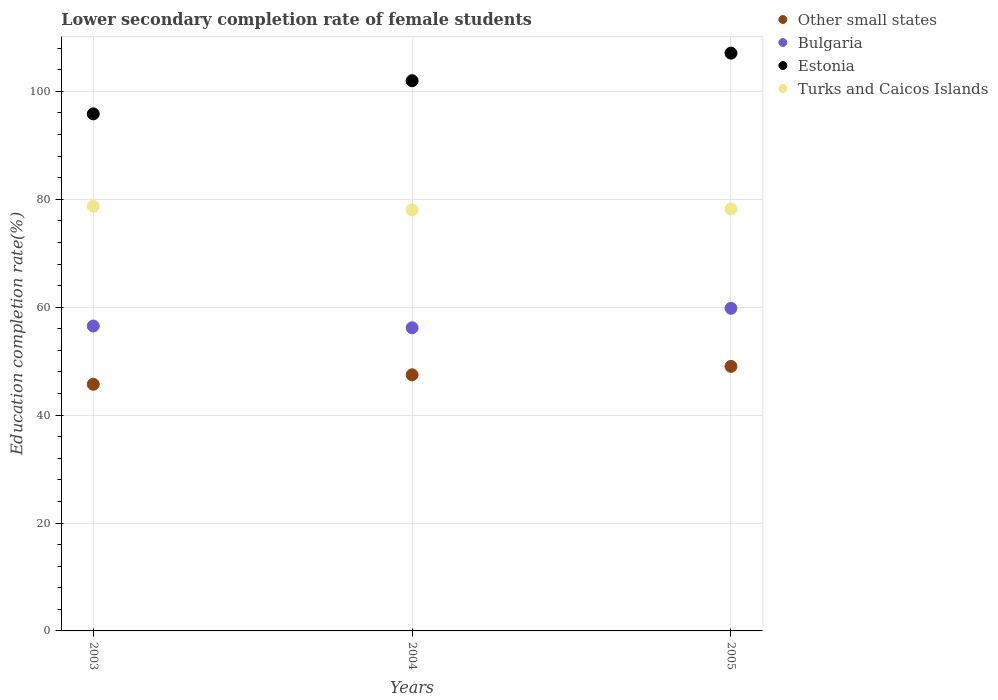Is the number of dotlines equal to the number of legend labels?
Offer a terse response. Yes. What is the lower secondary completion rate of female students in Turks and Caicos Islands in 2003?
Offer a terse response. 78.71. Across all years, what is the maximum lower secondary completion rate of female students in Bulgaria?
Your answer should be compact. 59.8. Across all years, what is the minimum lower secondary completion rate of female students in Other small states?
Give a very brief answer. 45.72. In which year was the lower secondary completion rate of female students in Bulgaria maximum?
Provide a short and direct response. 2005. What is the total lower secondary completion rate of female students in Turks and Caicos Islands in the graph?
Offer a terse response. 234.97. What is the difference between the lower secondary completion rate of female students in Other small states in 2004 and that in 2005?
Offer a very short reply. -1.56. What is the difference between the lower secondary completion rate of female students in Turks and Caicos Islands in 2003 and the lower secondary completion rate of female students in Other small states in 2005?
Ensure brevity in your answer.  29.68. What is the average lower secondary completion rate of female students in Bulgaria per year?
Give a very brief answer. 57.5. In the year 2003, what is the difference between the lower secondary completion rate of female students in Other small states and lower secondary completion rate of female students in Turks and Caicos Islands?
Your answer should be compact. -32.99. What is the ratio of the lower secondary completion rate of female students in Estonia in 2004 to that in 2005?
Your response must be concise. 0.95. What is the difference between the highest and the second highest lower secondary completion rate of female students in Bulgaria?
Keep it short and to the point. 3.28. What is the difference between the highest and the lowest lower secondary completion rate of female students in Estonia?
Make the answer very short. 11.26. Is the sum of the lower secondary completion rate of female students in Bulgaria in 2004 and 2005 greater than the maximum lower secondary completion rate of female students in Other small states across all years?
Provide a short and direct response. Yes. Is it the case that in every year, the sum of the lower secondary completion rate of female students in Bulgaria and lower secondary completion rate of female students in Turks and Caicos Islands  is greater than the sum of lower secondary completion rate of female students in Other small states and lower secondary completion rate of female students in Estonia?
Your response must be concise. No. Is it the case that in every year, the sum of the lower secondary completion rate of female students in Turks and Caicos Islands and lower secondary completion rate of female students in Estonia  is greater than the lower secondary completion rate of female students in Other small states?
Your answer should be very brief. Yes. Are the values on the major ticks of Y-axis written in scientific E-notation?
Your answer should be very brief. No. Does the graph contain any zero values?
Provide a short and direct response. No. Where does the legend appear in the graph?
Your answer should be very brief. Top right. How many legend labels are there?
Give a very brief answer. 4. What is the title of the graph?
Provide a succinct answer. Lower secondary completion rate of female students. Does "Tonga" appear as one of the legend labels in the graph?
Your answer should be compact. No. What is the label or title of the X-axis?
Your answer should be compact. Years. What is the label or title of the Y-axis?
Keep it short and to the point. Education completion rate(%). What is the Education completion rate(%) in Other small states in 2003?
Keep it short and to the point. 45.72. What is the Education completion rate(%) in Bulgaria in 2003?
Your answer should be very brief. 56.52. What is the Education completion rate(%) in Estonia in 2003?
Keep it short and to the point. 95.84. What is the Education completion rate(%) of Turks and Caicos Islands in 2003?
Provide a succinct answer. 78.71. What is the Education completion rate(%) in Other small states in 2004?
Offer a terse response. 47.47. What is the Education completion rate(%) of Bulgaria in 2004?
Your answer should be compact. 56.19. What is the Education completion rate(%) in Estonia in 2004?
Your answer should be very brief. 101.99. What is the Education completion rate(%) in Turks and Caicos Islands in 2004?
Give a very brief answer. 78.05. What is the Education completion rate(%) in Other small states in 2005?
Provide a short and direct response. 49.03. What is the Education completion rate(%) of Bulgaria in 2005?
Make the answer very short. 59.8. What is the Education completion rate(%) of Estonia in 2005?
Provide a short and direct response. 107.1. What is the Education completion rate(%) in Turks and Caicos Islands in 2005?
Your answer should be very brief. 78.21. Across all years, what is the maximum Education completion rate(%) of Other small states?
Keep it short and to the point. 49.03. Across all years, what is the maximum Education completion rate(%) in Bulgaria?
Your response must be concise. 59.8. Across all years, what is the maximum Education completion rate(%) of Estonia?
Provide a short and direct response. 107.1. Across all years, what is the maximum Education completion rate(%) in Turks and Caicos Islands?
Ensure brevity in your answer.  78.71. Across all years, what is the minimum Education completion rate(%) of Other small states?
Provide a succinct answer. 45.72. Across all years, what is the minimum Education completion rate(%) in Bulgaria?
Ensure brevity in your answer.  56.19. Across all years, what is the minimum Education completion rate(%) of Estonia?
Give a very brief answer. 95.84. Across all years, what is the minimum Education completion rate(%) in Turks and Caicos Islands?
Your answer should be very brief. 78.05. What is the total Education completion rate(%) of Other small states in the graph?
Your response must be concise. 142.22. What is the total Education completion rate(%) in Bulgaria in the graph?
Your answer should be very brief. 172.51. What is the total Education completion rate(%) of Estonia in the graph?
Offer a terse response. 304.92. What is the total Education completion rate(%) of Turks and Caicos Islands in the graph?
Offer a very short reply. 234.97. What is the difference between the Education completion rate(%) of Other small states in 2003 and that in 2004?
Your answer should be compact. -1.76. What is the difference between the Education completion rate(%) in Bulgaria in 2003 and that in 2004?
Your response must be concise. 0.33. What is the difference between the Education completion rate(%) of Estonia in 2003 and that in 2004?
Provide a short and direct response. -6.15. What is the difference between the Education completion rate(%) of Turks and Caicos Islands in 2003 and that in 2004?
Give a very brief answer. 0.66. What is the difference between the Education completion rate(%) in Other small states in 2003 and that in 2005?
Provide a succinct answer. -3.31. What is the difference between the Education completion rate(%) of Bulgaria in 2003 and that in 2005?
Keep it short and to the point. -3.28. What is the difference between the Education completion rate(%) in Estonia in 2003 and that in 2005?
Offer a terse response. -11.26. What is the difference between the Education completion rate(%) in Turks and Caicos Islands in 2003 and that in 2005?
Provide a short and direct response. 0.5. What is the difference between the Education completion rate(%) of Other small states in 2004 and that in 2005?
Your answer should be very brief. -1.56. What is the difference between the Education completion rate(%) of Bulgaria in 2004 and that in 2005?
Provide a succinct answer. -3.61. What is the difference between the Education completion rate(%) in Estonia in 2004 and that in 2005?
Your response must be concise. -5.11. What is the difference between the Education completion rate(%) in Turks and Caicos Islands in 2004 and that in 2005?
Make the answer very short. -0.16. What is the difference between the Education completion rate(%) of Other small states in 2003 and the Education completion rate(%) of Bulgaria in 2004?
Give a very brief answer. -10.47. What is the difference between the Education completion rate(%) in Other small states in 2003 and the Education completion rate(%) in Estonia in 2004?
Offer a very short reply. -56.27. What is the difference between the Education completion rate(%) in Other small states in 2003 and the Education completion rate(%) in Turks and Caicos Islands in 2004?
Make the answer very short. -32.33. What is the difference between the Education completion rate(%) in Bulgaria in 2003 and the Education completion rate(%) in Estonia in 2004?
Provide a short and direct response. -45.47. What is the difference between the Education completion rate(%) of Bulgaria in 2003 and the Education completion rate(%) of Turks and Caicos Islands in 2004?
Keep it short and to the point. -21.53. What is the difference between the Education completion rate(%) of Estonia in 2003 and the Education completion rate(%) of Turks and Caicos Islands in 2004?
Make the answer very short. 17.79. What is the difference between the Education completion rate(%) of Other small states in 2003 and the Education completion rate(%) of Bulgaria in 2005?
Provide a short and direct response. -14.08. What is the difference between the Education completion rate(%) of Other small states in 2003 and the Education completion rate(%) of Estonia in 2005?
Offer a terse response. -61.38. What is the difference between the Education completion rate(%) of Other small states in 2003 and the Education completion rate(%) of Turks and Caicos Islands in 2005?
Your response must be concise. -32.49. What is the difference between the Education completion rate(%) in Bulgaria in 2003 and the Education completion rate(%) in Estonia in 2005?
Provide a short and direct response. -50.58. What is the difference between the Education completion rate(%) of Bulgaria in 2003 and the Education completion rate(%) of Turks and Caicos Islands in 2005?
Provide a succinct answer. -21.7. What is the difference between the Education completion rate(%) in Estonia in 2003 and the Education completion rate(%) in Turks and Caicos Islands in 2005?
Your answer should be compact. 17.63. What is the difference between the Education completion rate(%) of Other small states in 2004 and the Education completion rate(%) of Bulgaria in 2005?
Give a very brief answer. -12.33. What is the difference between the Education completion rate(%) of Other small states in 2004 and the Education completion rate(%) of Estonia in 2005?
Provide a succinct answer. -59.62. What is the difference between the Education completion rate(%) in Other small states in 2004 and the Education completion rate(%) in Turks and Caicos Islands in 2005?
Your answer should be very brief. -30.74. What is the difference between the Education completion rate(%) of Bulgaria in 2004 and the Education completion rate(%) of Estonia in 2005?
Give a very brief answer. -50.91. What is the difference between the Education completion rate(%) in Bulgaria in 2004 and the Education completion rate(%) in Turks and Caicos Islands in 2005?
Provide a succinct answer. -22.02. What is the difference between the Education completion rate(%) of Estonia in 2004 and the Education completion rate(%) of Turks and Caicos Islands in 2005?
Offer a terse response. 23.77. What is the average Education completion rate(%) in Other small states per year?
Offer a very short reply. 47.41. What is the average Education completion rate(%) in Bulgaria per year?
Give a very brief answer. 57.5. What is the average Education completion rate(%) of Estonia per year?
Make the answer very short. 101.64. What is the average Education completion rate(%) in Turks and Caicos Islands per year?
Give a very brief answer. 78.32. In the year 2003, what is the difference between the Education completion rate(%) in Other small states and Education completion rate(%) in Bulgaria?
Ensure brevity in your answer.  -10.8. In the year 2003, what is the difference between the Education completion rate(%) of Other small states and Education completion rate(%) of Estonia?
Offer a terse response. -50.12. In the year 2003, what is the difference between the Education completion rate(%) in Other small states and Education completion rate(%) in Turks and Caicos Islands?
Ensure brevity in your answer.  -32.99. In the year 2003, what is the difference between the Education completion rate(%) of Bulgaria and Education completion rate(%) of Estonia?
Your response must be concise. -39.32. In the year 2003, what is the difference between the Education completion rate(%) of Bulgaria and Education completion rate(%) of Turks and Caicos Islands?
Ensure brevity in your answer.  -22.19. In the year 2003, what is the difference between the Education completion rate(%) of Estonia and Education completion rate(%) of Turks and Caicos Islands?
Ensure brevity in your answer.  17.13. In the year 2004, what is the difference between the Education completion rate(%) in Other small states and Education completion rate(%) in Bulgaria?
Provide a short and direct response. -8.72. In the year 2004, what is the difference between the Education completion rate(%) in Other small states and Education completion rate(%) in Estonia?
Give a very brief answer. -54.51. In the year 2004, what is the difference between the Education completion rate(%) in Other small states and Education completion rate(%) in Turks and Caicos Islands?
Make the answer very short. -30.57. In the year 2004, what is the difference between the Education completion rate(%) of Bulgaria and Education completion rate(%) of Estonia?
Keep it short and to the point. -45.8. In the year 2004, what is the difference between the Education completion rate(%) in Bulgaria and Education completion rate(%) in Turks and Caicos Islands?
Offer a terse response. -21.86. In the year 2004, what is the difference between the Education completion rate(%) of Estonia and Education completion rate(%) of Turks and Caicos Islands?
Keep it short and to the point. 23.94. In the year 2005, what is the difference between the Education completion rate(%) in Other small states and Education completion rate(%) in Bulgaria?
Your answer should be compact. -10.77. In the year 2005, what is the difference between the Education completion rate(%) in Other small states and Education completion rate(%) in Estonia?
Provide a short and direct response. -58.07. In the year 2005, what is the difference between the Education completion rate(%) in Other small states and Education completion rate(%) in Turks and Caicos Islands?
Provide a short and direct response. -29.18. In the year 2005, what is the difference between the Education completion rate(%) of Bulgaria and Education completion rate(%) of Estonia?
Your response must be concise. -47.3. In the year 2005, what is the difference between the Education completion rate(%) of Bulgaria and Education completion rate(%) of Turks and Caicos Islands?
Your response must be concise. -18.41. In the year 2005, what is the difference between the Education completion rate(%) of Estonia and Education completion rate(%) of Turks and Caicos Islands?
Your answer should be compact. 28.88. What is the ratio of the Education completion rate(%) of Estonia in 2003 to that in 2004?
Your response must be concise. 0.94. What is the ratio of the Education completion rate(%) of Turks and Caicos Islands in 2003 to that in 2004?
Your answer should be compact. 1.01. What is the ratio of the Education completion rate(%) of Other small states in 2003 to that in 2005?
Provide a succinct answer. 0.93. What is the ratio of the Education completion rate(%) of Bulgaria in 2003 to that in 2005?
Keep it short and to the point. 0.95. What is the ratio of the Education completion rate(%) in Estonia in 2003 to that in 2005?
Keep it short and to the point. 0.89. What is the ratio of the Education completion rate(%) of Turks and Caicos Islands in 2003 to that in 2005?
Make the answer very short. 1.01. What is the ratio of the Education completion rate(%) of Other small states in 2004 to that in 2005?
Offer a very short reply. 0.97. What is the ratio of the Education completion rate(%) of Bulgaria in 2004 to that in 2005?
Make the answer very short. 0.94. What is the ratio of the Education completion rate(%) in Estonia in 2004 to that in 2005?
Make the answer very short. 0.95. What is the difference between the highest and the second highest Education completion rate(%) of Other small states?
Provide a succinct answer. 1.56. What is the difference between the highest and the second highest Education completion rate(%) in Bulgaria?
Your answer should be very brief. 3.28. What is the difference between the highest and the second highest Education completion rate(%) in Estonia?
Give a very brief answer. 5.11. What is the difference between the highest and the second highest Education completion rate(%) of Turks and Caicos Islands?
Offer a terse response. 0.5. What is the difference between the highest and the lowest Education completion rate(%) in Other small states?
Provide a short and direct response. 3.31. What is the difference between the highest and the lowest Education completion rate(%) of Bulgaria?
Ensure brevity in your answer.  3.61. What is the difference between the highest and the lowest Education completion rate(%) of Estonia?
Your response must be concise. 11.26. What is the difference between the highest and the lowest Education completion rate(%) of Turks and Caicos Islands?
Provide a succinct answer. 0.66. 